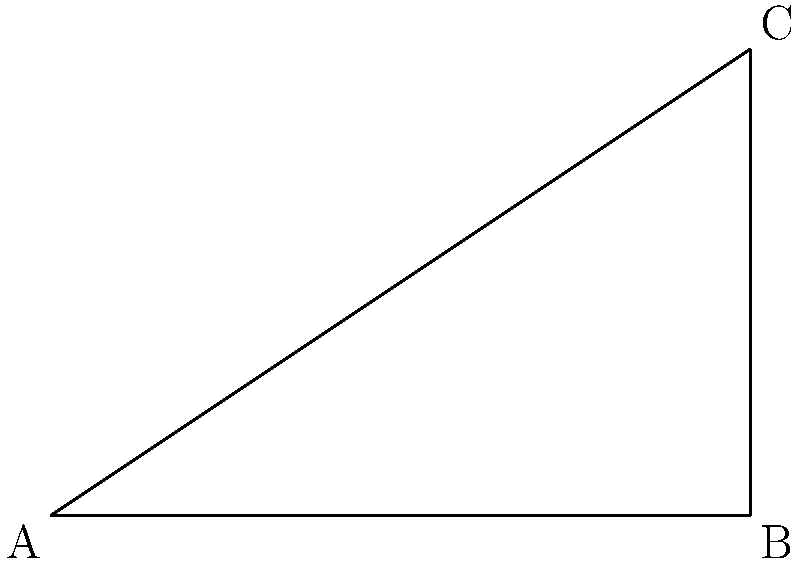The Magnolia Springs water tower is visible from two different observation points in the city. From point A, the angle of elevation to the top of the water tower is $\theta$. An observer then walks 100 meters closer to the base of the tower to point B, where the angle of elevation is now $\alpha$. If the height of the water tower is 50 meters, find the value of $\tan \theta$. Let's approach this step-by-step:

1) First, let's identify what we know:
   - The distance between points A and B is 100 meters
   - The height of the water tower is 50 meters
   - We need to find $\tan \theta$

2) Let's consider the right triangle ABC:
   - BC is the height of the tower (50 m)
   - AB is the distance between the observation points (100 m)
   - AC is the line of sight from point A to the top of the tower

3) In this triangle, $\tan \theta = \frac{BC}{AB+BC}$

4) We know BC = 50 m, but we don't know AC. However, we don't need to know AC to find $\tan \theta$.

5) Substituting the known values:

   $\tan \theta = \frac{50}{100+x}$

   Where x is the unknown distance from point B to the base of the tower.

6) We don't need to know the value of x or the angle $\alpha$ to solve for $\tan \theta$.

7) Therefore, we can directly calculate:

   $\tan \theta = \frac{50}{100+x} = \frac{50}{100} = \frac{1}{2} = 0.5$

Thus, the value of $\tan \theta$ is 0.5.
Answer: $0.5$ 